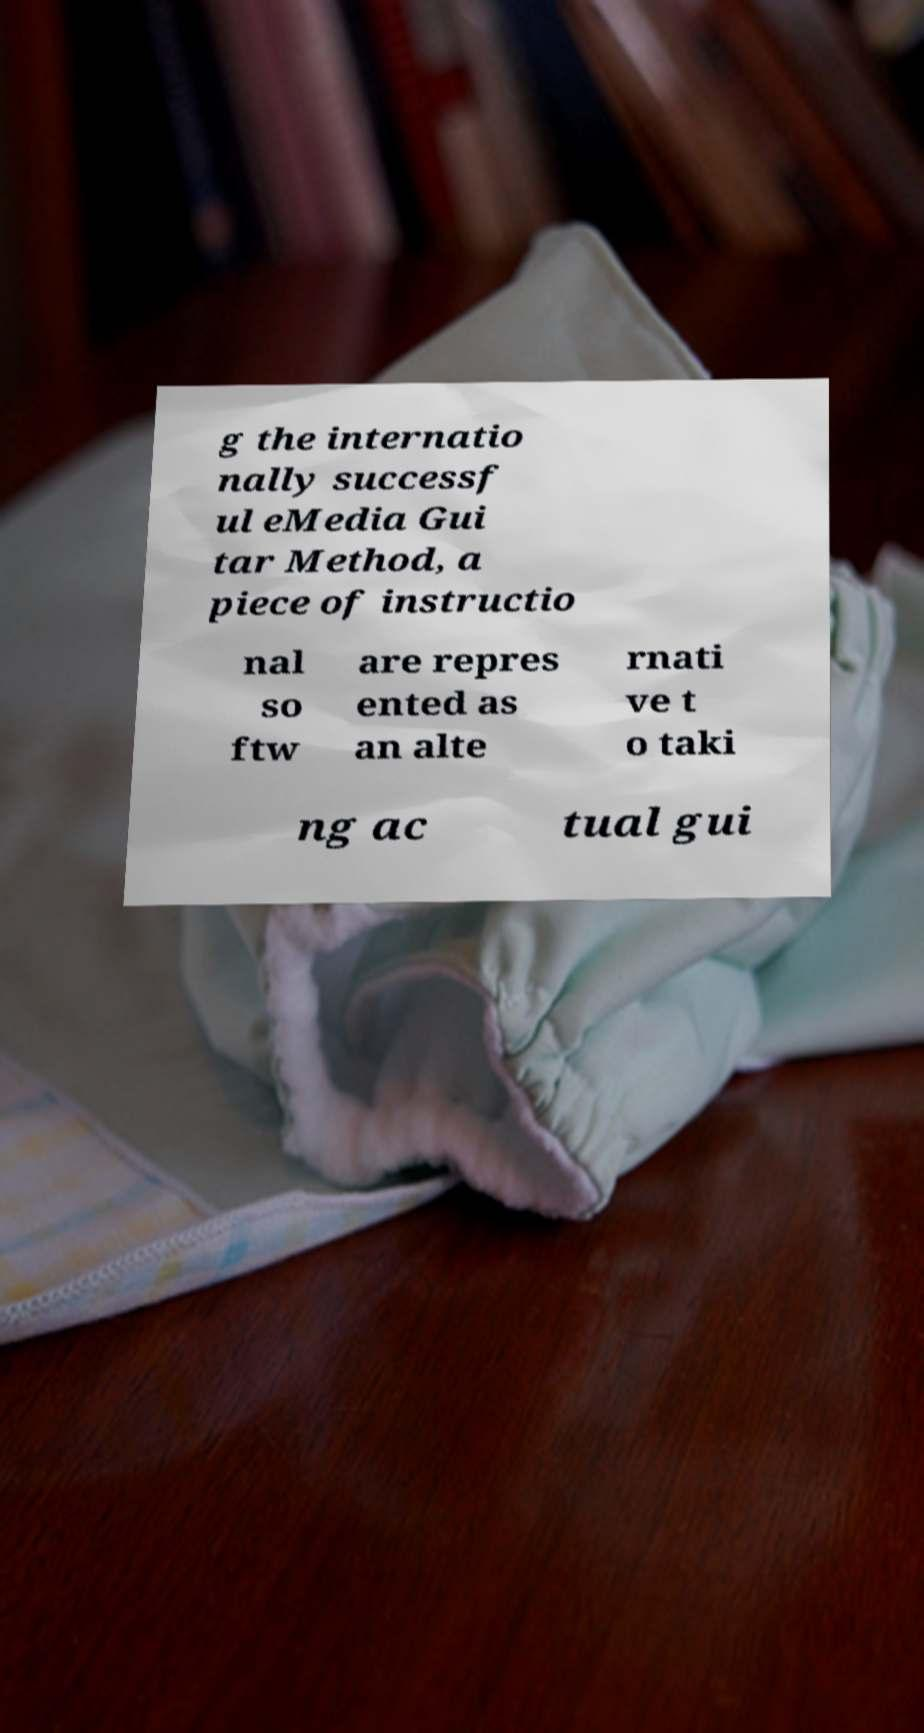There's text embedded in this image that I need extracted. Can you transcribe it verbatim? g the internatio nally successf ul eMedia Gui tar Method, a piece of instructio nal so ftw are repres ented as an alte rnati ve t o taki ng ac tual gui 